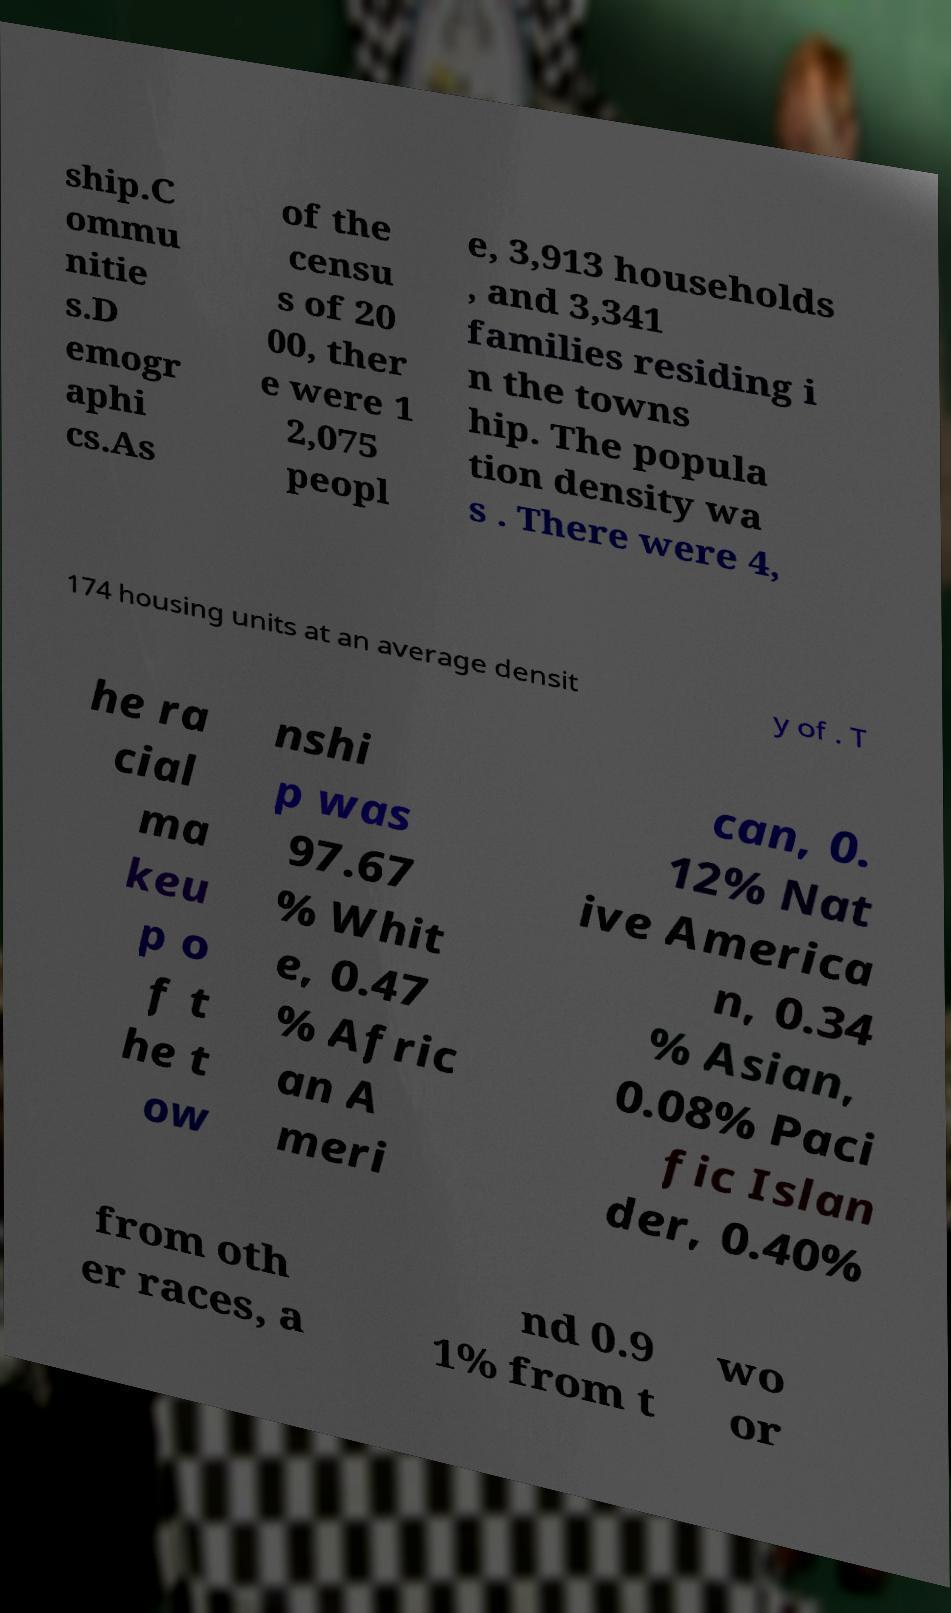Could you assist in decoding the text presented in this image and type it out clearly? ship.C ommu nitie s.D emogr aphi cs.As of the censu s of 20 00, ther e were 1 2,075 peopl e, 3,913 households , and 3,341 families residing i n the towns hip. The popula tion density wa s . There were 4, 174 housing units at an average densit y of . T he ra cial ma keu p o f t he t ow nshi p was 97.67 % Whit e, 0.47 % Afric an A meri can, 0. 12% Nat ive America n, 0.34 % Asian, 0.08% Paci fic Islan der, 0.40% from oth er races, a nd 0.9 1% from t wo or 